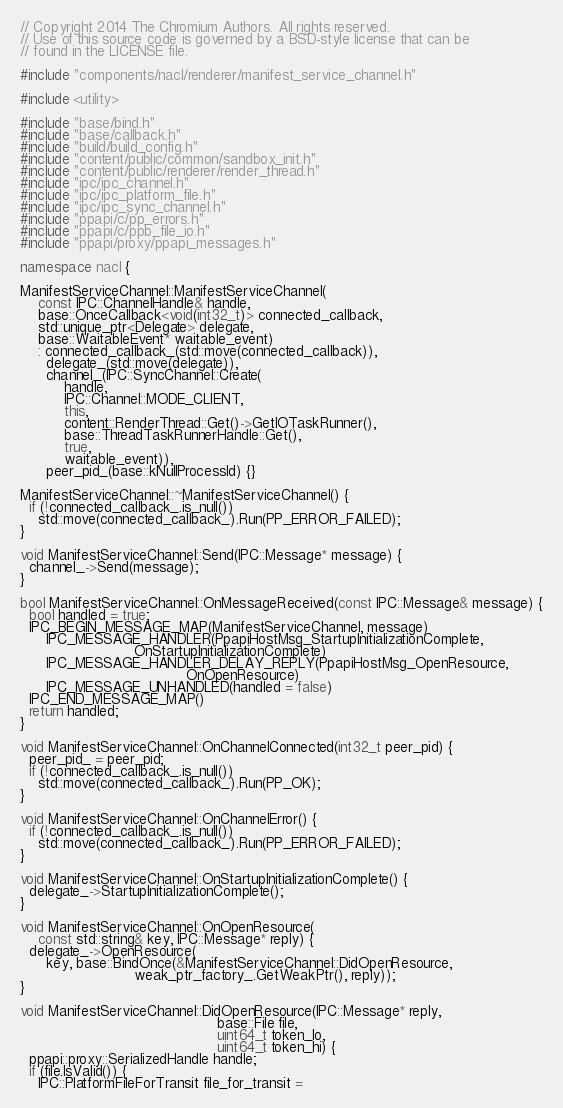<code> <loc_0><loc_0><loc_500><loc_500><_C++_>// Copyright 2014 The Chromium Authors. All rights reserved.
// Use of this source code is governed by a BSD-style license that can be
// found in the LICENSE file.

#include "components/nacl/renderer/manifest_service_channel.h"

#include <utility>

#include "base/bind.h"
#include "base/callback.h"
#include "build/build_config.h"
#include "content/public/common/sandbox_init.h"
#include "content/public/renderer/render_thread.h"
#include "ipc/ipc_channel.h"
#include "ipc/ipc_platform_file.h"
#include "ipc/ipc_sync_channel.h"
#include "ppapi/c/pp_errors.h"
#include "ppapi/c/ppb_file_io.h"
#include "ppapi/proxy/ppapi_messages.h"

namespace nacl {

ManifestServiceChannel::ManifestServiceChannel(
    const IPC::ChannelHandle& handle,
    base::OnceCallback<void(int32_t)> connected_callback,
    std::unique_ptr<Delegate> delegate,
    base::WaitableEvent* waitable_event)
    : connected_callback_(std::move(connected_callback)),
      delegate_(std::move(delegate)),
      channel_(IPC::SyncChannel::Create(
          handle,
          IPC::Channel::MODE_CLIENT,
          this,
          content::RenderThread::Get()->GetIOTaskRunner(),
          base::ThreadTaskRunnerHandle::Get(),
          true,
          waitable_event)),
      peer_pid_(base::kNullProcessId) {}

ManifestServiceChannel::~ManifestServiceChannel() {
  if (!connected_callback_.is_null())
    std::move(connected_callback_).Run(PP_ERROR_FAILED);
}

void ManifestServiceChannel::Send(IPC::Message* message) {
  channel_->Send(message);
}

bool ManifestServiceChannel::OnMessageReceived(const IPC::Message& message) {
  bool handled = true;
  IPC_BEGIN_MESSAGE_MAP(ManifestServiceChannel, message)
      IPC_MESSAGE_HANDLER(PpapiHostMsg_StartupInitializationComplete,
                          OnStartupInitializationComplete)
      IPC_MESSAGE_HANDLER_DELAY_REPLY(PpapiHostMsg_OpenResource,
                                      OnOpenResource)
      IPC_MESSAGE_UNHANDLED(handled = false)
  IPC_END_MESSAGE_MAP()
  return handled;
}

void ManifestServiceChannel::OnChannelConnected(int32_t peer_pid) {
  peer_pid_ = peer_pid;
  if (!connected_callback_.is_null())
    std::move(connected_callback_).Run(PP_OK);
}

void ManifestServiceChannel::OnChannelError() {
  if (!connected_callback_.is_null())
    std::move(connected_callback_).Run(PP_ERROR_FAILED);
}

void ManifestServiceChannel::OnStartupInitializationComplete() {
  delegate_->StartupInitializationComplete();
}

void ManifestServiceChannel::OnOpenResource(
    const std::string& key, IPC::Message* reply) {
  delegate_->OpenResource(
      key, base::BindOnce(&ManifestServiceChannel::DidOpenResource,
                          weak_ptr_factory_.GetWeakPtr(), reply));
}

void ManifestServiceChannel::DidOpenResource(IPC::Message* reply,
                                             base::File file,
                                             uint64_t token_lo,
                                             uint64_t token_hi) {
  ppapi::proxy::SerializedHandle handle;
  if (file.IsValid()) {
    IPC::PlatformFileForTransit file_for_transit =</code> 